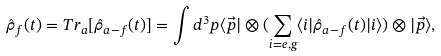Convert formula to latex. <formula><loc_0><loc_0><loc_500><loc_500>\hat { \rho } _ { f } ( t ) = T r _ { a } [ \hat { \rho } _ { a - f } ( t ) ] = \int d ^ { 3 } p \langle \vec { p } | \otimes ( \sum _ { i = e , g } \langle i | \hat { \rho } _ { a - f } ( t ) | i \rangle ) \otimes | \vec { p } \rangle ,</formula> 